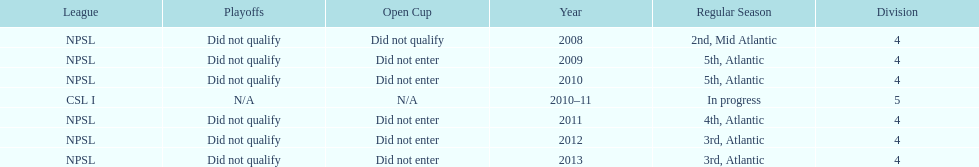How many 3rd place finishes has npsl had? 2. 